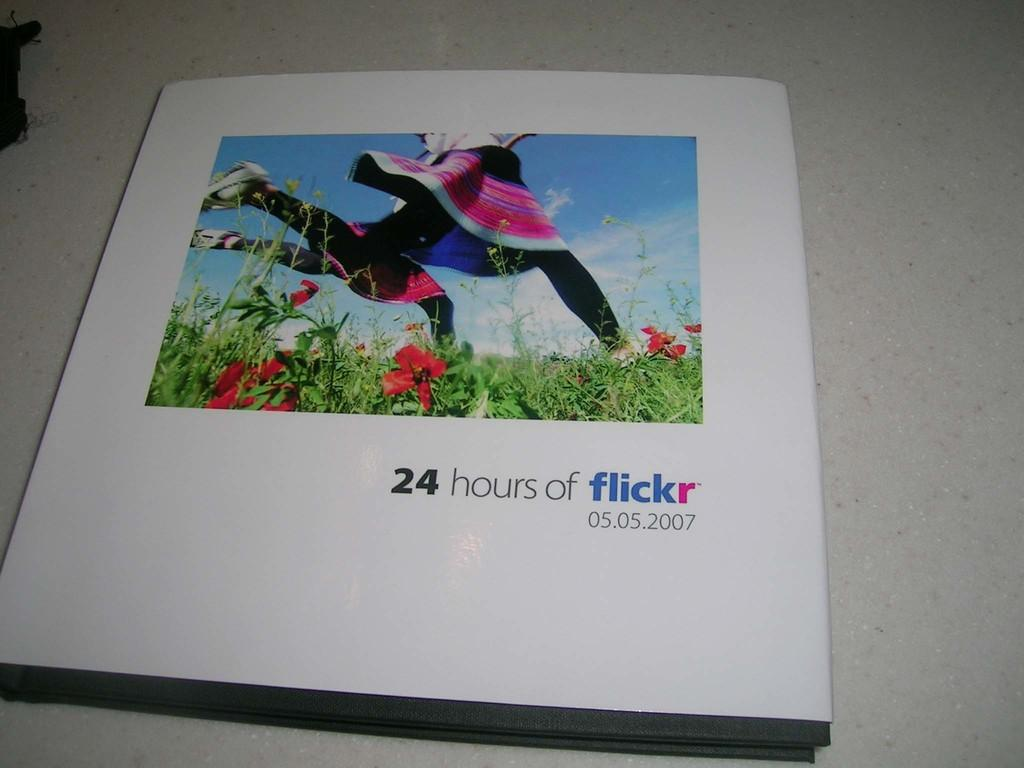What object can be seen in the image? There is a book in the image. What is located behind the book? There is a table behind the book. What type of spy equipment can be seen hanging from the curtain in the image? There is no curtain or spy equipment present in the image; it only features a book and a table. How many tomatoes are visible on the table in the image? There are no tomatoes present in the image; it only features a book and a table. 